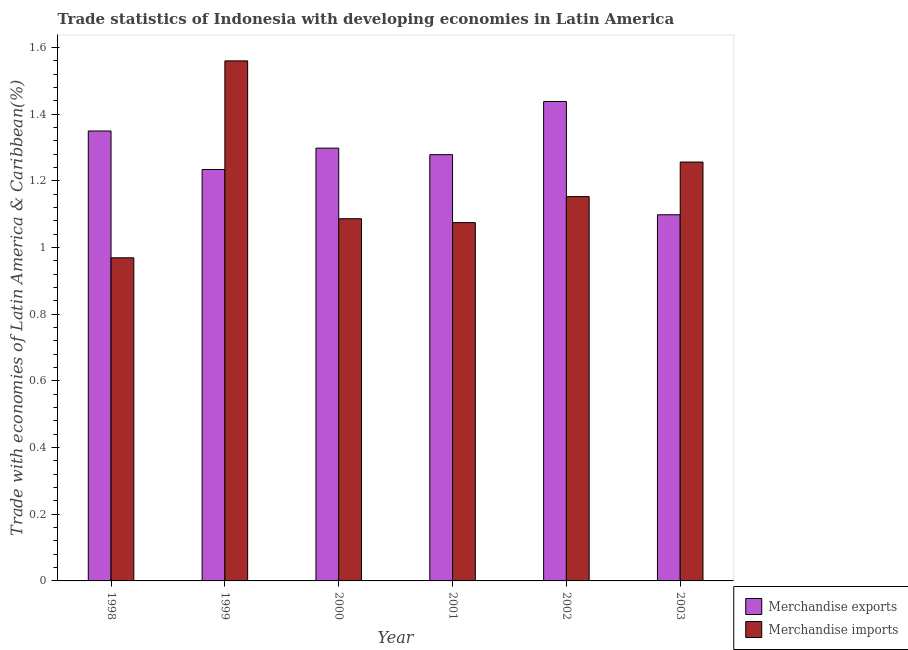How many different coloured bars are there?
Provide a succinct answer. 2. Are the number of bars per tick equal to the number of legend labels?
Make the answer very short. Yes. Are the number of bars on each tick of the X-axis equal?
Provide a short and direct response. Yes. How many bars are there on the 2nd tick from the right?
Keep it short and to the point. 2. What is the label of the 4th group of bars from the left?
Provide a succinct answer. 2001. In how many cases, is the number of bars for a given year not equal to the number of legend labels?
Provide a short and direct response. 0. What is the merchandise imports in 2003?
Your response must be concise. 1.26. Across all years, what is the maximum merchandise exports?
Provide a succinct answer. 1.44. Across all years, what is the minimum merchandise exports?
Provide a succinct answer. 1.1. In which year was the merchandise imports maximum?
Keep it short and to the point. 1999. What is the total merchandise exports in the graph?
Ensure brevity in your answer.  7.7. What is the difference between the merchandise imports in 1999 and that in 2002?
Keep it short and to the point. 0.41. What is the difference between the merchandise exports in 1998 and the merchandise imports in 2002?
Make the answer very short. -0.09. What is the average merchandise exports per year?
Provide a short and direct response. 1.28. In how many years, is the merchandise exports greater than 1.4400000000000002 %?
Offer a terse response. 0. What is the ratio of the merchandise imports in 1998 to that in 2003?
Your answer should be compact. 0.77. Is the difference between the merchandise imports in 1999 and 2002 greater than the difference between the merchandise exports in 1999 and 2002?
Your answer should be compact. No. What is the difference between the highest and the second highest merchandise exports?
Offer a terse response. 0.09. What is the difference between the highest and the lowest merchandise exports?
Your response must be concise. 0.34. What does the 1st bar from the right in 2003 represents?
Provide a short and direct response. Merchandise imports. How many bars are there?
Your answer should be very brief. 12. What is the difference between two consecutive major ticks on the Y-axis?
Give a very brief answer. 0.2. Are the values on the major ticks of Y-axis written in scientific E-notation?
Make the answer very short. No. Does the graph contain any zero values?
Your response must be concise. No. Where does the legend appear in the graph?
Make the answer very short. Bottom right. How many legend labels are there?
Your answer should be very brief. 2. How are the legend labels stacked?
Your answer should be very brief. Vertical. What is the title of the graph?
Make the answer very short. Trade statistics of Indonesia with developing economies in Latin America. What is the label or title of the Y-axis?
Your answer should be compact. Trade with economies of Latin America & Caribbean(%). What is the Trade with economies of Latin America & Caribbean(%) of Merchandise exports in 1998?
Ensure brevity in your answer.  1.35. What is the Trade with economies of Latin America & Caribbean(%) in Merchandise imports in 1998?
Make the answer very short. 0.97. What is the Trade with economies of Latin America & Caribbean(%) in Merchandise exports in 1999?
Offer a very short reply. 1.23. What is the Trade with economies of Latin America & Caribbean(%) in Merchandise imports in 1999?
Provide a succinct answer. 1.56. What is the Trade with economies of Latin America & Caribbean(%) in Merchandise exports in 2000?
Make the answer very short. 1.3. What is the Trade with economies of Latin America & Caribbean(%) of Merchandise imports in 2000?
Your answer should be very brief. 1.09. What is the Trade with economies of Latin America & Caribbean(%) of Merchandise exports in 2001?
Your answer should be compact. 1.28. What is the Trade with economies of Latin America & Caribbean(%) of Merchandise imports in 2001?
Offer a very short reply. 1.07. What is the Trade with economies of Latin America & Caribbean(%) of Merchandise exports in 2002?
Your answer should be very brief. 1.44. What is the Trade with economies of Latin America & Caribbean(%) in Merchandise imports in 2002?
Provide a succinct answer. 1.15. What is the Trade with economies of Latin America & Caribbean(%) in Merchandise exports in 2003?
Ensure brevity in your answer.  1.1. What is the Trade with economies of Latin America & Caribbean(%) in Merchandise imports in 2003?
Give a very brief answer. 1.26. Across all years, what is the maximum Trade with economies of Latin America & Caribbean(%) in Merchandise exports?
Your answer should be compact. 1.44. Across all years, what is the maximum Trade with economies of Latin America & Caribbean(%) of Merchandise imports?
Provide a short and direct response. 1.56. Across all years, what is the minimum Trade with economies of Latin America & Caribbean(%) of Merchandise exports?
Offer a very short reply. 1.1. Across all years, what is the minimum Trade with economies of Latin America & Caribbean(%) of Merchandise imports?
Offer a terse response. 0.97. What is the total Trade with economies of Latin America & Caribbean(%) of Merchandise exports in the graph?
Your answer should be very brief. 7.7. What is the total Trade with economies of Latin America & Caribbean(%) in Merchandise imports in the graph?
Make the answer very short. 7.1. What is the difference between the Trade with economies of Latin America & Caribbean(%) of Merchandise exports in 1998 and that in 1999?
Make the answer very short. 0.12. What is the difference between the Trade with economies of Latin America & Caribbean(%) in Merchandise imports in 1998 and that in 1999?
Offer a very short reply. -0.59. What is the difference between the Trade with economies of Latin America & Caribbean(%) of Merchandise exports in 1998 and that in 2000?
Keep it short and to the point. 0.05. What is the difference between the Trade with economies of Latin America & Caribbean(%) in Merchandise imports in 1998 and that in 2000?
Keep it short and to the point. -0.12. What is the difference between the Trade with economies of Latin America & Caribbean(%) in Merchandise exports in 1998 and that in 2001?
Ensure brevity in your answer.  0.07. What is the difference between the Trade with economies of Latin America & Caribbean(%) in Merchandise imports in 1998 and that in 2001?
Provide a short and direct response. -0.11. What is the difference between the Trade with economies of Latin America & Caribbean(%) in Merchandise exports in 1998 and that in 2002?
Give a very brief answer. -0.09. What is the difference between the Trade with economies of Latin America & Caribbean(%) in Merchandise imports in 1998 and that in 2002?
Your answer should be very brief. -0.18. What is the difference between the Trade with economies of Latin America & Caribbean(%) of Merchandise exports in 1998 and that in 2003?
Ensure brevity in your answer.  0.25. What is the difference between the Trade with economies of Latin America & Caribbean(%) of Merchandise imports in 1998 and that in 2003?
Ensure brevity in your answer.  -0.29. What is the difference between the Trade with economies of Latin America & Caribbean(%) in Merchandise exports in 1999 and that in 2000?
Offer a very short reply. -0.06. What is the difference between the Trade with economies of Latin America & Caribbean(%) in Merchandise imports in 1999 and that in 2000?
Make the answer very short. 0.47. What is the difference between the Trade with economies of Latin America & Caribbean(%) of Merchandise exports in 1999 and that in 2001?
Offer a very short reply. -0.04. What is the difference between the Trade with economies of Latin America & Caribbean(%) in Merchandise imports in 1999 and that in 2001?
Offer a terse response. 0.49. What is the difference between the Trade with economies of Latin America & Caribbean(%) in Merchandise exports in 1999 and that in 2002?
Offer a terse response. -0.2. What is the difference between the Trade with economies of Latin America & Caribbean(%) of Merchandise imports in 1999 and that in 2002?
Make the answer very short. 0.41. What is the difference between the Trade with economies of Latin America & Caribbean(%) of Merchandise exports in 1999 and that in 2003?
Your answer should be compact. 0.14. What is the difference between the Trade with economies of Latin America & Caribbean(%) of Merchandise imports in 1999 and that in 2003?
Your answer should be very brief. 0.3. What is the difference between the Trade with economies of Latin America & Caribbean(%) of Merchandise exports in 2000 and that in 2001?
Your answer should be compact. 0.02. What is the difference between the Trade with economies of Latin America & Caribbean(%) of Merchandise imports in 2000 and that in 2001?
Provide a succinct answer. 0.01. What is the difference between the Trade with economies of Latin America & Caribbean(%) in Merchandise exports in 2000 and that in 2002?
Ensure brevity in your answer.  -0.14. What is the difference between the Trade with economies of Latin America & Caribbean(%) in Merchandise imports in 2000 and that in 2002?
Your answer should be very brief. -0.07. What is the difference between the Trade with economies of Latin America & Caribbean(%) in Merchandise exports in 2000 and that in 2003?
Give a very brief answer. 0.2. What is the difference between the Trade with economies of Latin America & Caribbean(%) of Merchandise imports in 2000 and that in 2003?
Offer a very short reply. -0.17. What is the difference between the Trade with economies of Latin America & Caribbean(%) of Merchandise exports in 2001 and that in 2002?
Offer a terse response. -0.16. What is the difference between the Trade with economies of Latin America & Caribbean(%) in Merchandise imports in 2001 and that in 2002?
Offer a very short reply. -0.08. What is the difference between the Trade with economies of Latin America & Caribbean(%) of Merchandise exports in 2001 and that in 2003?
Your answer should be compact. 0.18. What is the difference between the Trade with economies of Latin America & Caribbean(%) of Merchandise imports in 2001 and that in 2003?
Your answer should be very brief. -0.18. What is the difference between the Trade with economies of Latin America & Caribbean(%) in Merchandise exports in 2002 and that in 2003?
Ensure brevity in your answer.  0.34. What is the difference between the Trade with economies of Latin America & Caribbean(%) in Merchandise imports in 2002 and that in 2003?
Provide a short and direct response. -0.1. What is the difference between the Trade with economies of Latin America & Caribbean(%) of Merchandise exports in 1998 and the Trade with economies of Latin America & Caribbean(%) of Merchandise imports in 1999?
Keep it short and to the point. -0.21. What is the difference between the Trade with economies of Latin America & Caribbean(%) in Merchandise exports in 1998 and the Trade with economies of Latin America & Caribbean(%) in Merchandise imports in 2000?
Your answer should be very brief. 0.26. What is the difference between the Trade with economies of Latin America & Caribbean(%) in Merchandise exports in 1998 and the Trade with economies of Latin America & Caribbean(%) in Merchandise imports in 2001?
Provide a short and direct response. 0.27. What is the difference between the Trade with economies of Latin America & Caribbean(%) in Merchandise exports in 1998 and the Trade with economies of Latin America & Caribbean(%) in Merchandise imports in 2002?
Your answer should be compact. 0.2. What is the difference between the Trade with economies of Latin America & Caribbean(%) in Merchandise exports in 1998 and the Trade with economies of Latin America & Caribbean(%) in Merchandise imports in 2003?
Give a very brief answer. 0.09. What is the difference between the Trade with economies of Latin America & Caribbean(%) of Merchandise exports in 1999 and the Trade with economies of Latin America & Caribbean(%) of Merchandise imports in 2000?
Offer a terse response. 0.15. What is the difference between the Trade with economies of Latin America & Caribbean(%) in Merchandise exports in 1999 and the Trade with economies of Latin America & Caribbean(%) in Merchandise imports in 2001?
Keep it short and to the point. 0.16. What is the difference between the Trade with economies of Latin America & Caribbean(%) of Merchandise exports in 1999 and the Trade with economies of Latin America & Caribbean(%) of Merchandise imports in 2002?
Your answer should be compact. 0.08. What is the difference between the Trade with economies of Latin America & Caribbean(%) of Merchandise exports in 1999 and the Trade with economies of Latin America & Caribbean(%) of Merchandise imports in 2003?
Provide a short and direct response. -0.02. What is the difference between the Trade with economies of Latin America & Caribbean(%) of Merchandise exports in 2000 and the Trade with economies of Latin America & Caribbean(%) of Merchandise imports in 2001?
Your response must be concise. 0.22. What is the difference between the Trade with economies of Latin America & Caribbean(%) in Merchandise exports in 2000 and the Trade with economies of Latin America & Caribbean(%) in Merchandise imports in 2002?
Offer a terse response. 0.15. What is the difference between the Trade with economies of Latin America & Caribbean(%) of Merchandise exports in 2000 and the Trade with economies of Latin America & Caribbean(%) of Merchandise imports in 2003?
Offer a terse response. 0.04. What is the difference between the Trade with economies of Latin America & Caribbean(%) of Merchandise exports in 2001 and the Trade with economies of Latin America & Caribbean(%) of Merchandise imports in 2002?
Offer a very short reply. 0.13. What is the difference between the Trade with economies of Latin America & Caribbean(%) in Merchandise exports in 2001 and the Trade with economies of Latin America & Caribbean(%) in Merchandise imports in 2003?
Your answer should be compact. 0.02. What is the difference between the Trade with economies of Latin America & Caribbean(%) of Merchandise exports in 2002 and the Trade with economies of Latin America & Caribbean(%) of Merchandise imports in 2003?
Offer a very short reply. 0.18. What is the average Trade with economies of Latin America & Caribbean(%) of Merchandise exports per year?
Give a very brief answer. 1.28. What is the average Trade with economies of Latin America & Caribbean(%) in Merchandise imports per year?
Your answer should be compact. 1.18. In the year 1998, what is the difference between the Trade with economies of Latin America & Caribbean(%) of Merchandise exports and Trade with economies of Latin America & Caribbean(%) of Merchandise imports?
Ensure brevity in your answer.  0.38. In the year 1999, what is the difference between the Trade with economies of Latin America & Caribbean(%) of Merchandise exports and Trade with economies of Latin America & Caribbean(%) of Merchandise imports?
Offer a terse response. -0.33. In the year 2000, what is the difference between the Trade with economies of Latin America & Caribbean(%) in Merchandise exports and Trade with economies of Latin America & Caribbean(%) in Merchandise imports?
Ensure brevity in your answer.  0.21. In the year 2001, what is the difference between the Trade with economies of Latin America & Caribbean(%) of Merchandise exports and Trade with economies of Latin America & Caribbean(%) of Merchandise imports?
Your answer should be compact. 0.2. In the year 2002, what is the difference between the Trade with economies of Latin America & Caribbean(%) in Merchandise exports and Trade with economies of Latin America & Caribbean(%) in Merchandise imports?
Offer a terse response. 0.29. In the year 2003, what is the difference between the Trade with economies of Latin America & Caribbean(%) in Merchandise exports and Trade with economies of Latin America & Caribbean(%) in Merchandise imports?
Ensure brevity in your answer.  -0.16. What is the ratio of the Trade with economies of Latin America & Caribbean(%) of Merchandise exports in 1998 to that in 1999?
Keep it short and to the point. 1.09. What is the ratio of the Trade with economies of Latin America & Caribbean(%) of Merchandise imports in 1998 to that in 1999?
Ensure brevity in your answer.  0.62. What is the ratio of the Trade with economies of Latin America & Caribbean(%) of Merchandise exports in 1998 to that in 2000?
Keep it short and to the point. 1.04. What is the ratio of the Trade with economies of Latin America & Caribbean(%) of Merchandise imports in 1998 to that in 2000?
Keep it short and to the point. 0.89. What is the ratio of the Trade with economies of Latin America & Caribbean(%) of Merchandise exports in 1998 to that in 2001?
Give a very brief answer. 1.06. What is the ratio of the Trade with economies of Latin America & Caribbean(%) of Merchandise imports in 1998 to that in 2001?
Offer a terse response. 0.9. What is the ratio of the Trade with economies of Latin America & Caribbean(%) of Merchandise exports in 1998 to that in 2002?
Your answer should be compact. 0.94. What is the ratio of the Trade with economies of Latin America & Caribbean(%) in Merchandise imports in 1998 to that in 2002?
Provide a succinct answer. 0.84. What is the ratio of the Trade with economies of Latin America & Caribbean(%) of Merchandise exports in 1998 to that in 2003?
Make the answer very short. 1.23. What is the ratio of the Trade with economies of Latin America & Caribbean(%) in Merchandise imports in 1998 to that in 2003?
Keep it short and to the point. 0.77. What is the ratio of the Trade with economies of Latin America & Caribbean(%) of Merchandise exports in 1999 to that in 2000?
Provide a short and direct response. 0.95. What is the ratio of the Trade with economies of Latin America & Caribbean(%) of Merchandise imports in 1999 to that in 2000?
Your answer should be very brief. 1.44. What is the ratio of the Trade with economies of Latin America & Caribbean(%) of Merchandise exports in 1999 to that in 2001?
Give a very brief answer. 0.97. What is the ratio of the Trade with economies of Latin America & Caribbean(%) of Merchandise imports in 1999 to that in 2001?
Ensure brevity in your answer.  1.45. What is the ratio of the Trade with economies of Latin America & Caribbean(%) in Merchandise exports in 1999 to that in 2002?
Your response must be concise. 0.86. What is the ratio of the Trade with economies of Latin America & Caribbean(%) of Merchandise imports in 1999 to that in 2002?
Your answer should be compact. 1.35. What is the ratio of the Trade with economies of Latin America & Caribbean(%) of Merchandise exports in 1999 to that in 2003?
Ensure brevity in your answer.  1.12. What is the ratio of the Trade with economies of Latin America & Caribbean(%) in Merchandise imports in 1999 to that in 2003?
Offer a very short reply. 1.24. What is the ratio of the Trade with economies of Latin America & Caribbean(%) of Merchandise exports in 2000 to that in 2001?
Keep it short and to the point. 1.02. What is the ratio of the Trade with economies of Latin America & Caribbean(%) of Merchandise imports in 2000 to that in 2001?
Offer a terse response. 1.01. What is the ratio of the Trade with economies of Latin America & Caribbean(%) in Merchandise exports in 2000 to that in 2002?
Your response must be concise. 0.9. What is the ratio of the Trade with economies of Latin America & Caribbean(%) of Merchandise imports in 2000 to that in 2002?
Offer a very short reply. 0.94. What is the ratio of the Trade with economies of Latin America & Caribbean(%) in Merchandise exports in 2000 to that in 2003?
Offer a very short reply. 1.18. What is the ratio of the Trade with economies of Latin America & Caribbean(%) of Merchandise imports in 2000 to that in 2003?
Your answer should be compact. 0.86. What is the ratio of the Trade with economies of Latin America & Caribbean(%) of Merchandise exports in 2001 to that in 2002?
Make the answer very short. 0.89. What is the ratio of the Trade with economies of Latin America & Caribbean(%) of Merchandise imports in 2001 to that in 2002?
Your answer should be compact. 0.93. What is the ratio of the Trade with economies of Latin America & Caribbean(%) of Merchandise exports in 2001 to that in 2003?
Make the answer very short. 1.16. What is the ratio of the Trade with economies of Latin America & Caribbean(%) of Merchandise imports in 2001 to that in 2003?
Make the answer very short. 0.86. What is the ratio of the Trade with economies of Latin America & Caribbean(%) in Merchandise exports in 2002 to that in 2003?
Offer a terse response. 1.31. What is the ratio of the Trade with economies of Latin America & Caribbean(%) in Merchandise imports in 2002 to that in 2003?
Your response must be concise. 0.92. What is the difference between the highest and the second highest Trade with economies of Latin America & Caribbean(%) in Merchandise exports?
Your answer should be very brief. 0.09. What is the difference between the highest and the second highest Trade with economies of Latin America & Caribbean(%) in Merchandise imports?
Ensure brevity in your answer.  0.3. What is the difference between the highest and the lowest Trade with economies of Latin America & Caribbean(%) of Merchandise exports?
Your answer should be very brief. 0.34. What is the difference between the highest and the lowest Trade with economies of Latin America & Caribbean(%) in Merchandise imports?
Keep it short and to the point. 0.59. 